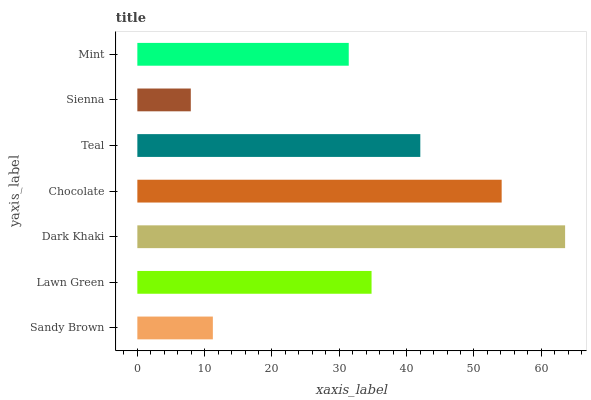Is Sienna the minimum?
Answer yes or no. Yes. Is Dark Khaki the maximum?
Answer yes or no. Yes. Is Lawn Green the minimum?
Answer yes or no. No. Is Lawn Green the maximum?
Answer yes or no. No. Is Lawn Green greater than Sandy Brown?
Answer yes or no. Yes. Is Sandy Brown less than Lawn Green?
Answer yes or no. Yes. Is Sandy Brown greater than Lawn Green?
Answer yes or no. No. Is Lawn Green less than Sandy Brown?
Answer yes or no. No. Is Lawn Green the high median?
Answer yes or no. Yes. Is Lawn Green the low median?
Answer yes or no. Yes. Is Mint the high median?
Answer yes or no. No. Is Teal the low median?
Answer yes or no. No. 